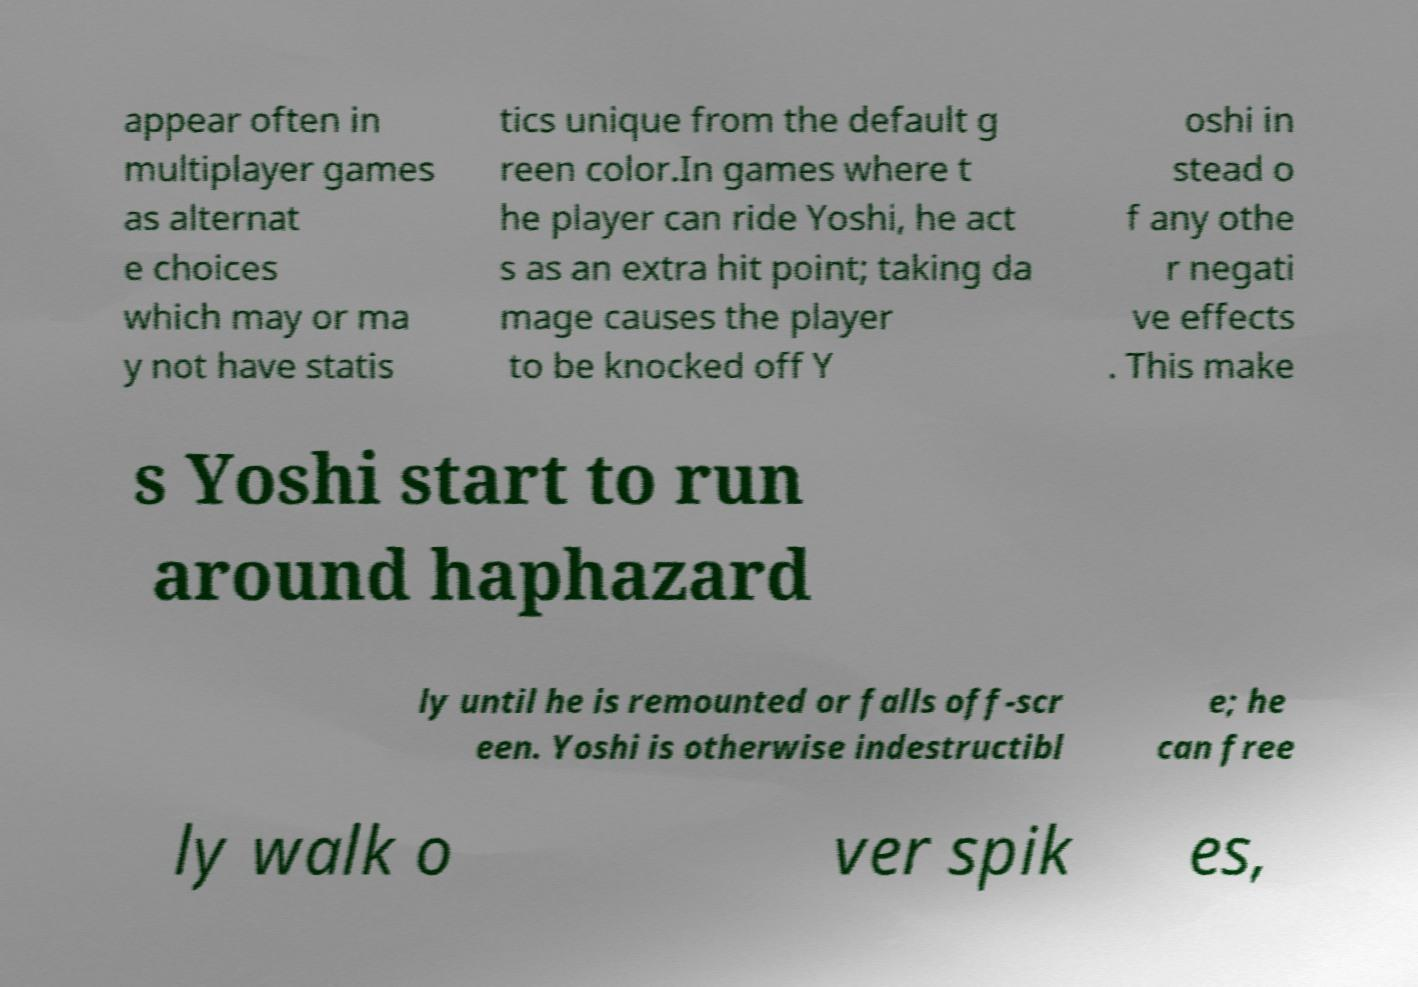Please identify and transcribe the text found in this image. appear often in multiplayer games as alternat e choices which may or ma y not have statis tics unique from the default g reen color.In games where t he player can ride Yoshi, he act s as an extra hit point; taking da mage causes the player to be knocked off Y oshi in stead o f any othe r negati ve effects . This make s Yoshi start to run around haphazard ly until he is remounted or falls off-scr een. Yoshi is otherwise indestructibl e; he can free ly walk o ver spik es, 